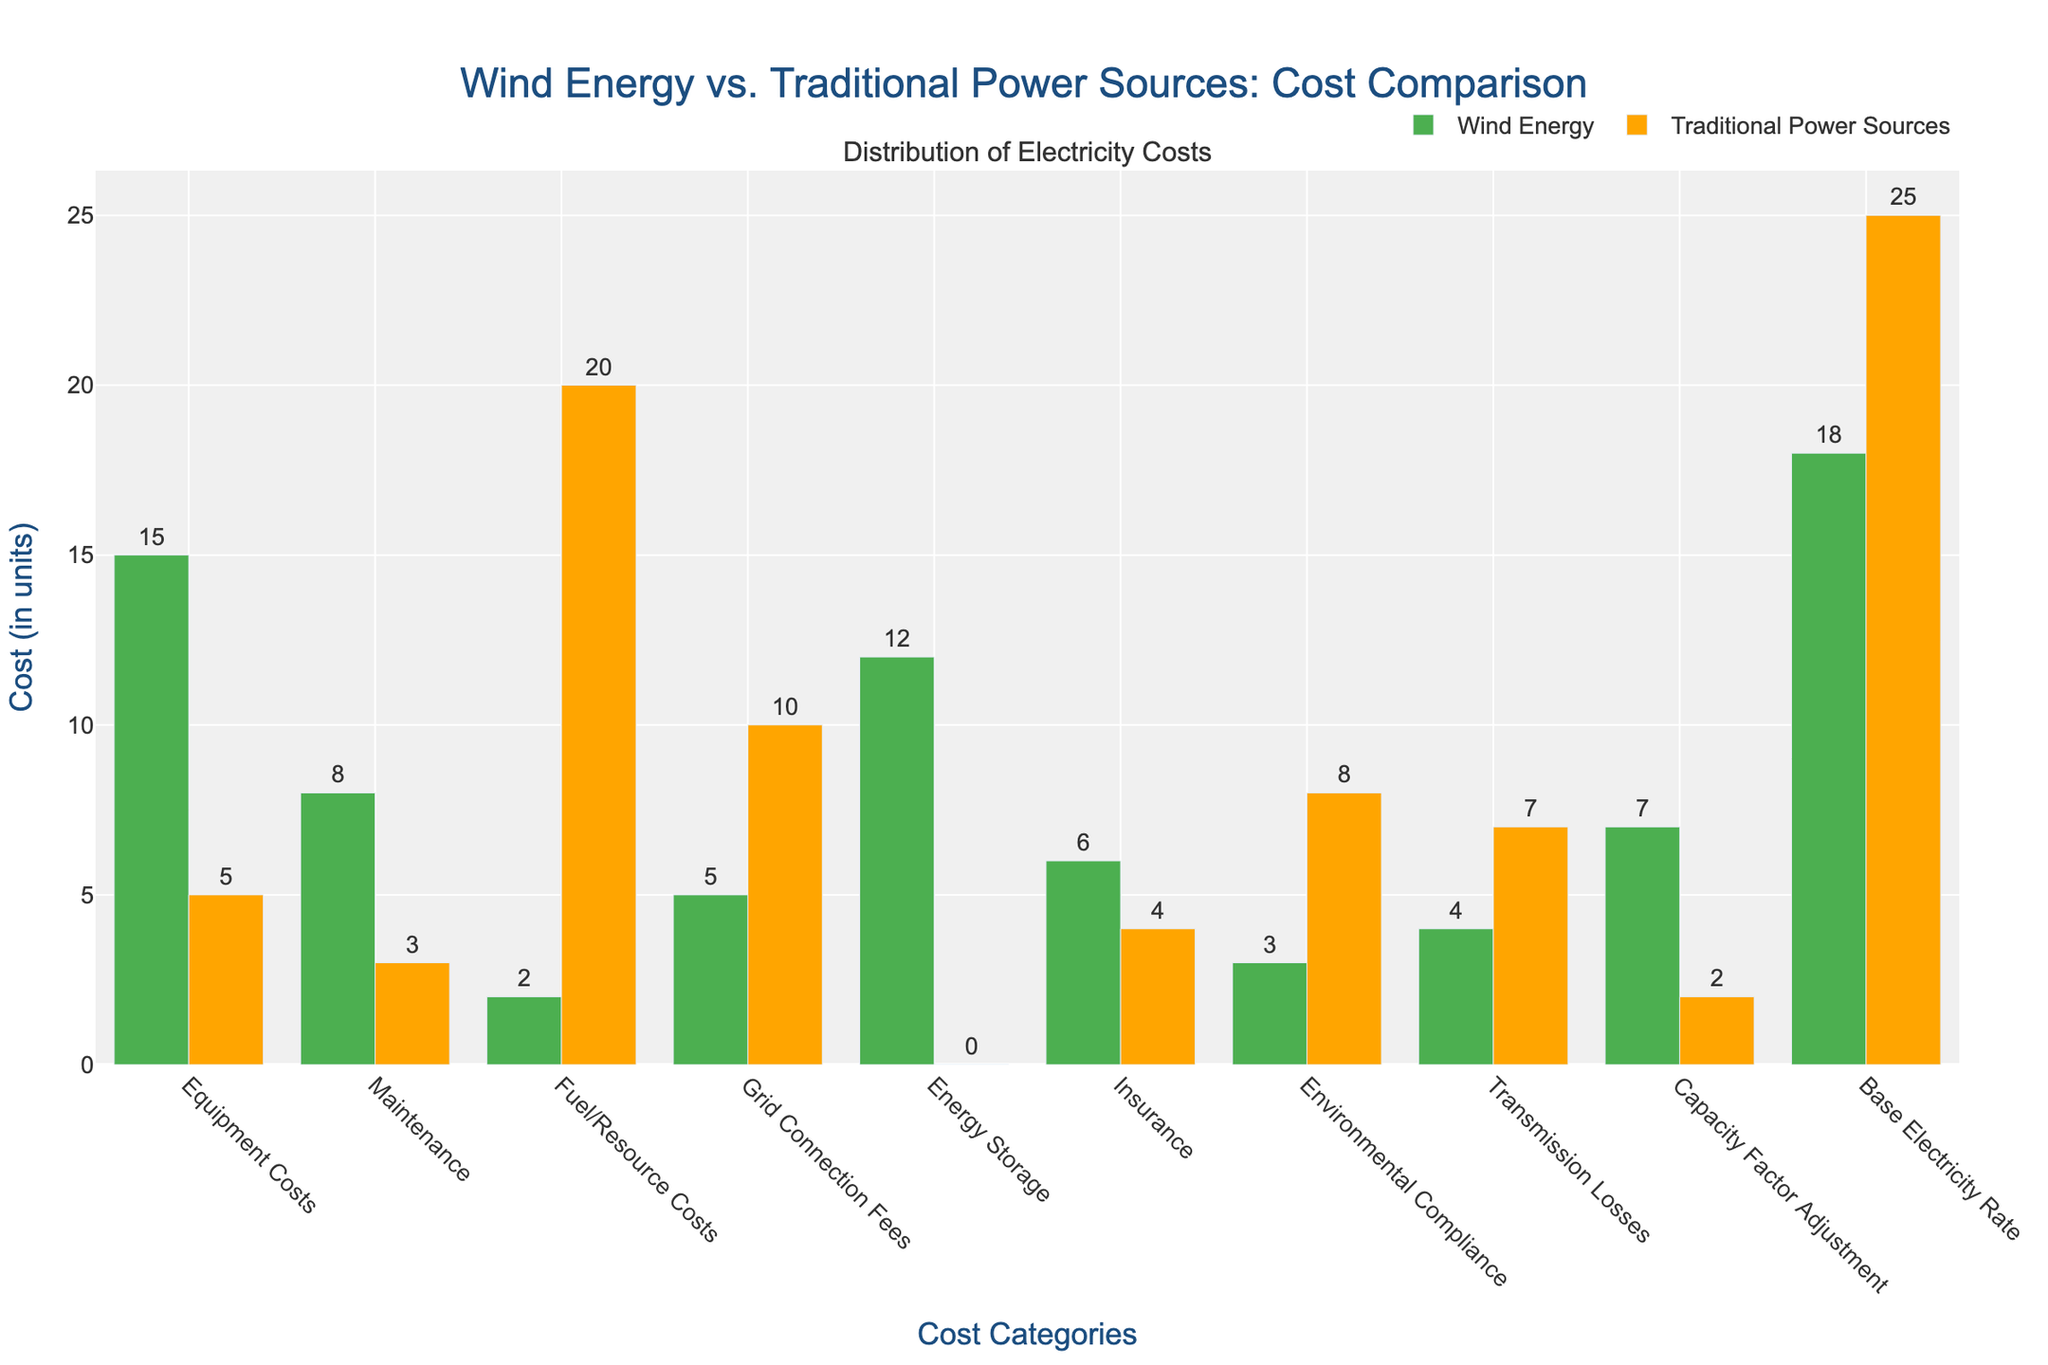Which category has the highest cost for Wind Energy? The highest bar for Wind Energy is for the 'Base Electricity Rate' category. This indicates that 'Base Electricity Rate' has the highest cost among all categories for Wind Energy.
Answer: Base Electricity Rate Which category has the lowest cost for Traditional Power Sources? The smallest bar for Traditional Power Sources is for 'Energy Storage'. This indicates that 'Energy Storage' has the lowest cost among all categories for Traditional Power Sources.
Answer: Energy Storage How much more does 'Environmental Compliance' cost for Traditional Power Sources compared to Wind Energy? The bar for 'Environmental Compliance' in Traditional Power Sources is at 8, while for Wind Energy it is at 3. Therefore, the difference is 8 - 3.
Answer: 5 What is the total cost for 'Equipment Costs' for both Wind Energy and Traditional Power Sources combined? The cost for 'Equipment Costs' for Wind Energy is 15 and for Traditional Power Sources is 5. So, the total is 15 + 5.
Answer: 20 What categories have a higher cost in Wind Energy than in Traditional Power Sources? By comparing each pair of bars, 'Equipment Costs', 'Maintenance', 'Energy Storage', 'Insurance', and 'Capacity Factor Adjustment' have higher bars for Wind Energy than for Traditional Power Sources.
Answer: Equipment Costs, Maintenance, Energy Storage, Insurance, Capacity Factor Adjustment Which energy source has lower grid connection fees? The grid connection fee for Wind Energy is 5, while for Traditional Power Sources it is 10. Since 5 is less than 10, Wind Energy has lower grid connection fees.
Answer: Wind Energy What is the sum of 'Base Electricity Rate' and 'Fuel/Resource Costs' for each energy source? For Wind Energy, the sum is 18 (Base Electricity Rate) + 2 (Fuel/Resource Costs) = 20. For Traditional Power Sources, the sum is 25 (Base Electricity Rate) + 20 (Fuel/Resource Costs) = 45.
Answer: Wind Energy: 20, Traditional Power Sources: 45 How does the cost of 'Transmission Losses' compare between the two energy sources? The cost of 'Transmission Losses' for Wind Energy is 4, whereas for Traditional Power Sources it is 7. Thus, Traditional Power Sources have higher 'Transmission Losses'.
Answer: Traditional Power Sources What is the average cost of 'Maintenance' for both energy sources? The cost of 'Maintenance' is 8 for Wind Energy and 3 for Traditional Power Sources. Therefore, the average is (8 + 3) / 2.
Answer: 5.5 